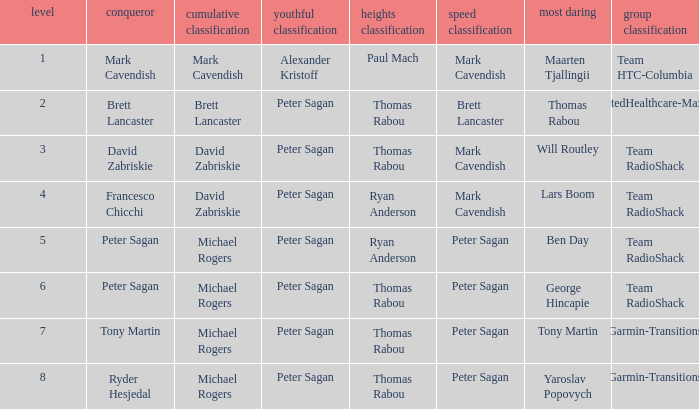When Ryan Anderson won the mountains classification, and Michael Rogers won the general classification, who won the sprint classification? Peter Sagan. Could you parse the entire table as a dict? {'header': ['level', 'conqueror', 'cumulative classification', 'youthful classification', 'heights classification', 'speed classification', 'most daring', 'group classification'], 'rows': [['1', 'Mark Cavendish', 'Mark Cavendish', 'Alexander Kristoff', 'Paul Mach', 'Mark Cavendish', 'Maarten Tjallingii', 'Team HTC-Columbia'], ['2', 'Brett Lancaster', 'Brett Lancaster', 'Peter Sagan', 'Thomas Rabou', 'Brett Lancaster', 'Thomas Rabou', 'UnitedHealthcare-Maxxis'], ['3', 'David Zabriskie', 'David Zabriskie', 'Peter Sagan', 'Thomas Rabou', 'Mark Cavendish', 'Will Routley', 'Team RadioShack'], ['4', 'Francesco Chicchi', 'David Zabriskie', 'Peter Sagan', 'Ryan Anderson', 'Mark Cavendish', 'Lars Boom', 'Team RadioShack'], ['5', 'Peter Sagan', 'Michael Rogers', 'Peter Sagan', 'Ryan Anderson', 'Peter Sagan', 'Ben Day', 'Team RadioShack'], ['6', 'Peter Sagan', 'Michael Rogers', 'Peter Sagan', 'Thomas Rabou', 'Peter Sagan', 'George Hincapie', 'Team RadioShack'], ['7', 'Tony Martin', 'Michael Rogers', 'Peter Sagan', 'Thomas Rabou', 'Peter Sagan', 'Tony Martin', 'Garmin-Transitions'], ['8', 'Ryder Hesjedal', 'Michael Rogers', 'Peter Sagan', 'Thomas Rabou', 'Peter Sagan', 'Yaroslav Popovych', 'Garmin-Transitions']]} 